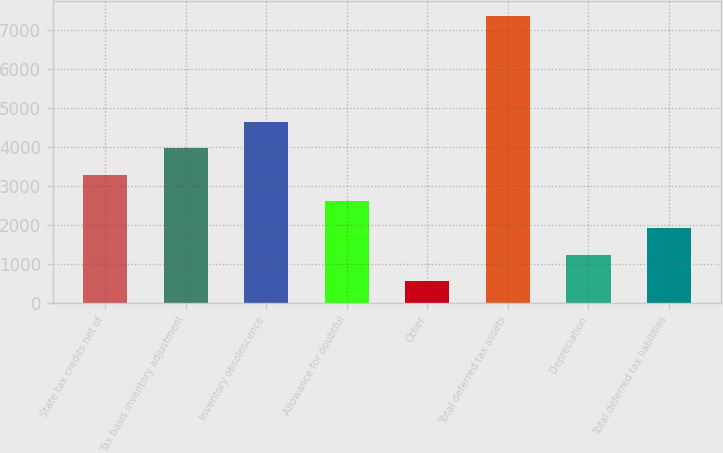<chart> <loc_0><loc_0><loc_500><loc_500><bar_chart><fcel>State tax credits net of<fcel>Tax basis inventory adjustment<fcel>Inventory obsolescence<fcel>Allowance for doubtful<fcel>Other<fcel>Total deferred tax assets<fcel>Depreciation<fcel>Total deferred tax liabilities<nl><fcel>3284.2<fcel>3966<fcel>4647.8<fcel>2602.4<fcel>557<fcel>7375<fcel>1238.8<fcel>1920.6<nl></chart> 